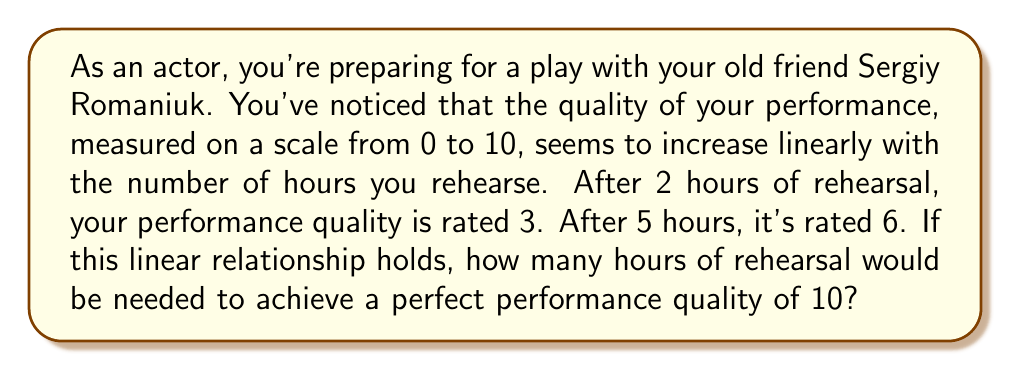Teach me how to tackle this problem. Let's approach this step-by-step:

1) Let $x$ be the number of hours of rehearsal and $y$ be the performance quality.

2) We can use the point-slope form of a linear equation: $y - y_1 = m(x - x_1)$

3) We need to find the slope $m$ first. We can use the two given points: (2, 3) and (5, 6)

   $m = \frac{y_2 - y_1}{x_2 - x_1} = \frac{6 - 3}{5 - 2} = \frac{3}{3} = 1$

4) Now we can use either point to write the equation. Let's use (2, 3):

   $y - 3 = 1(x - 2)$

5) Simplify:

   $y = x - 2 + 3 = x + 1$

6) This is our linear equation relating rehearsal time to performance quality.

7) For a perfect performance (y = 10), we can solve:

   $10 = x + 1$
   $x = 9$

Therefore, 9 hours of rehearsal would be needed for a perfect performance.
Answer: 9 hours 